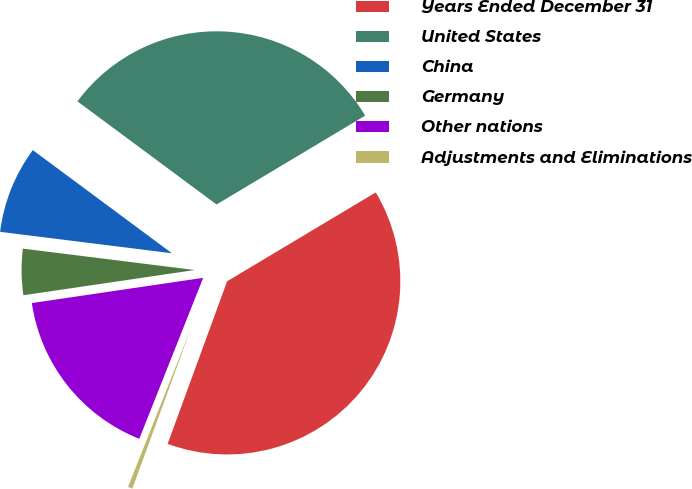<chart> <loc_0><loc_0><loc_500><loc_500><pie_chart><fcel>Years Ended December 31<fcel>United States<fcel>China<fcel>Germany<fcel>Other nations<fcel>Adjustments and Eliminations<nl><fcel>39.16%<fcel>31.27%<fcel>8.18%<fcel>4.3%<fcel>16.66%<fcel>0.43%<nl></chart> 